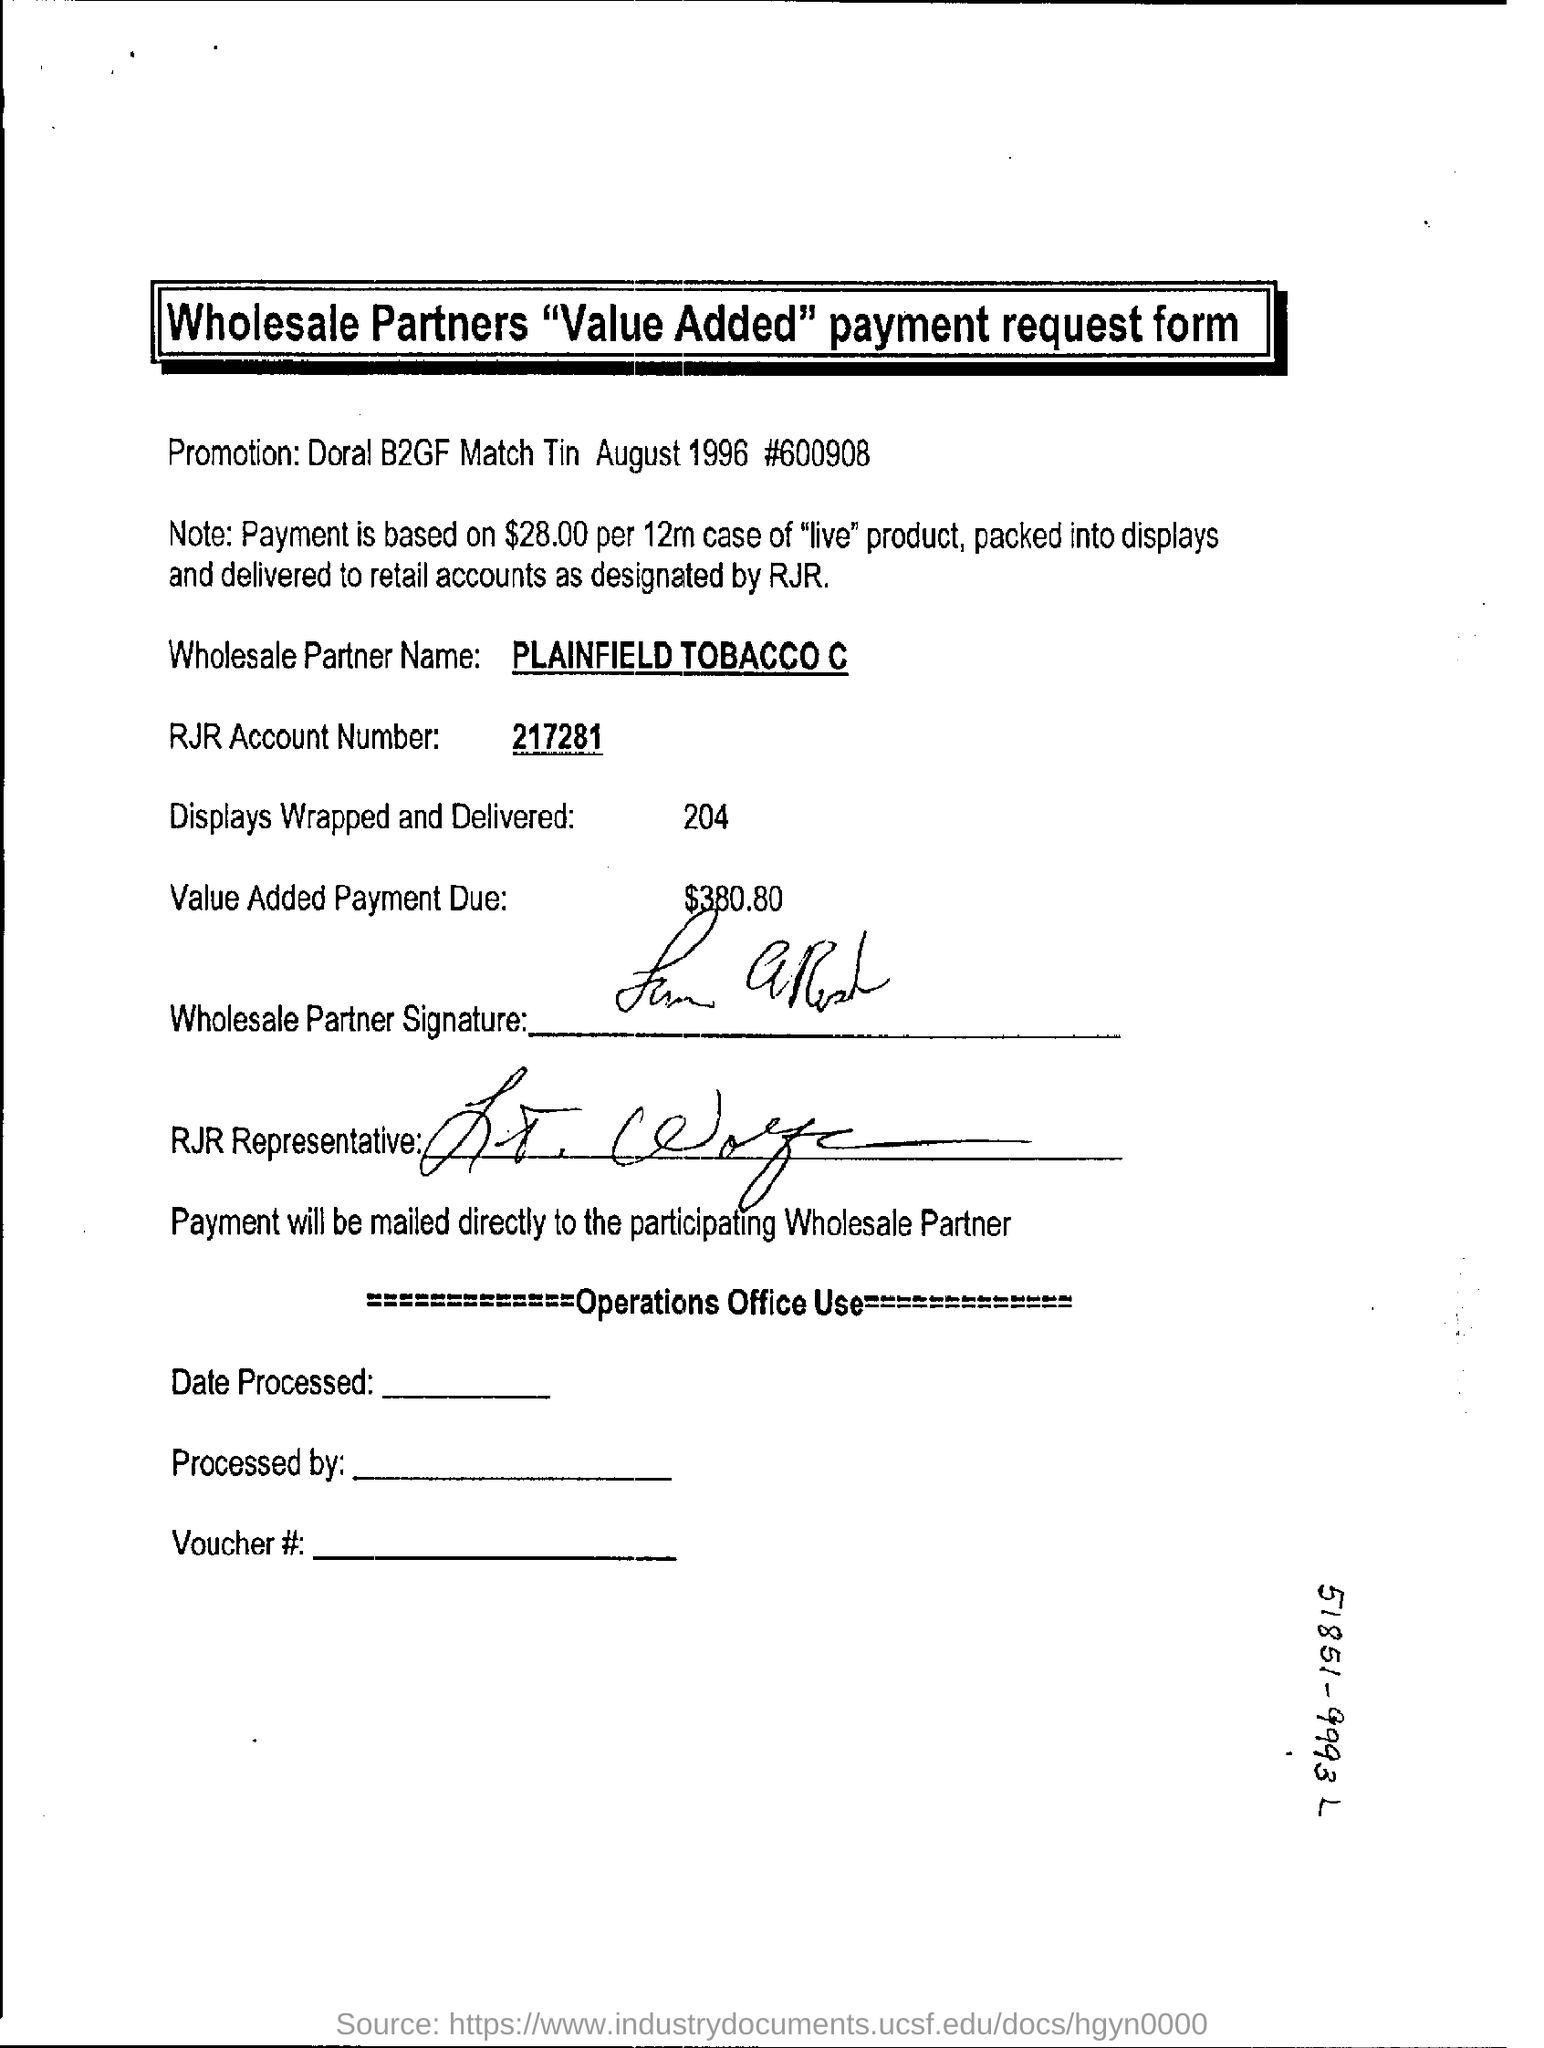Highlight a few significant elements in this photo. The RJR account number given is 217281. The number 217281 refers to an RJR account number. The wholesale partner name is PLAINFIELD TOBACCO CO. The number of displays that have been wrapped and delivered is 204. 